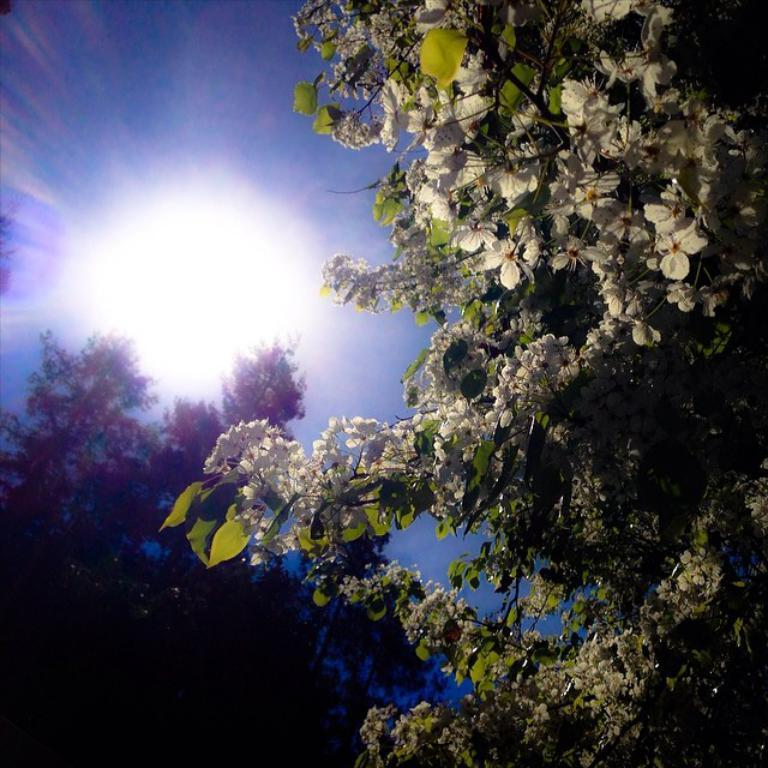What type of vegetation is present in the image? There are flowering trees in the image. Can you describe the lighting conditions in the image? There is light visible in the image. What part of the natural environment is visible in the image? The sky is visible in the image. Based on the presence of light, what time of day might the image have been taken? The image might have been taken during night, as there is light visible. What substance is being played with on the playground in the image? There is no playground or substance present in the image; it features flowering trees and a visible sky. 